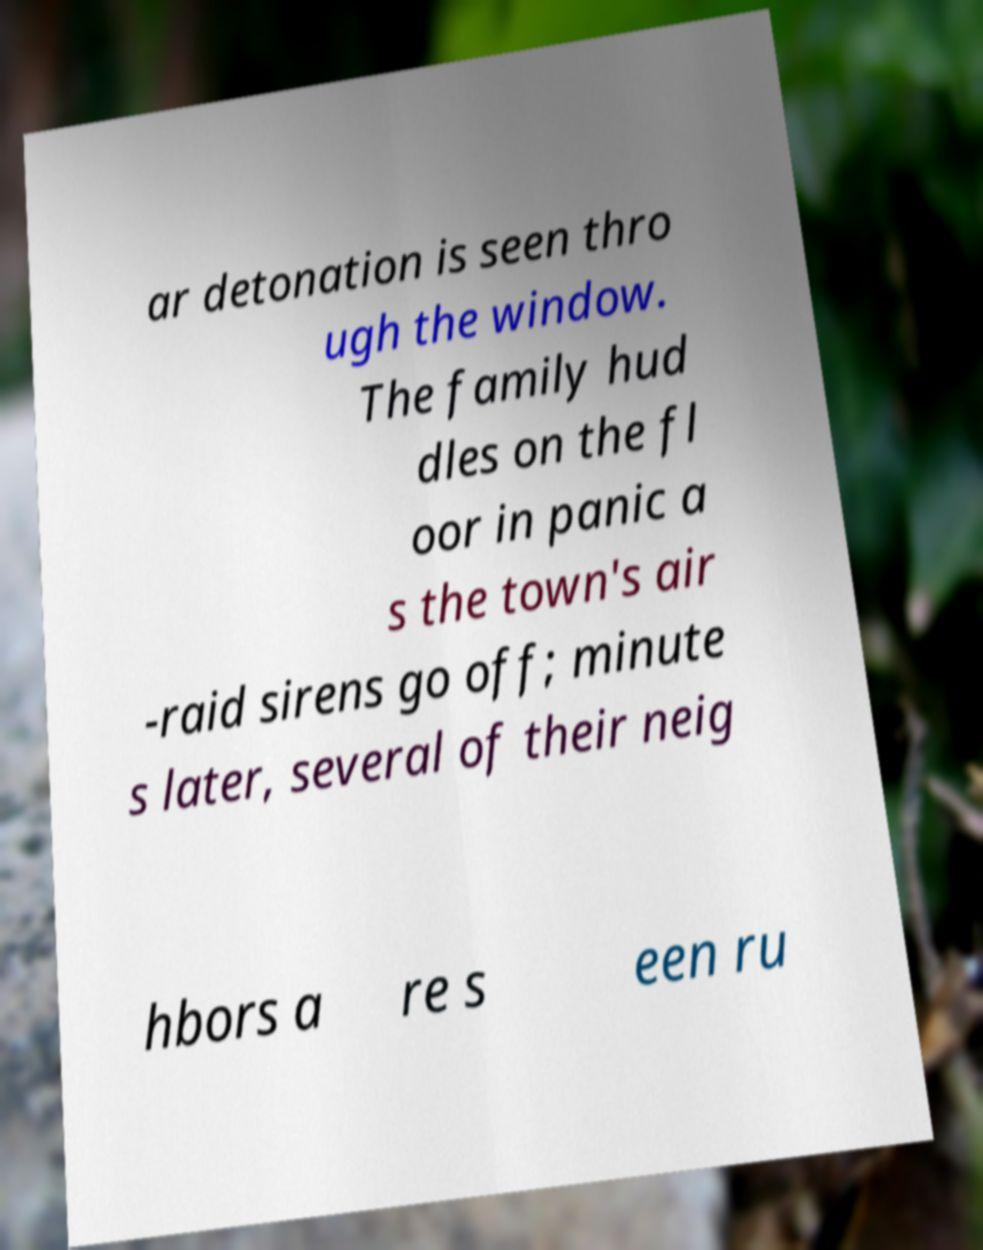For documentation purposes, I need the text within this image transcribed. Could you provide that? ar detonation is seen thro ugh the window. The family hud dles on the fl oor in panic a s the town's air -raid sirens go off; minute s later, several of their neig hbors a re s een ru 